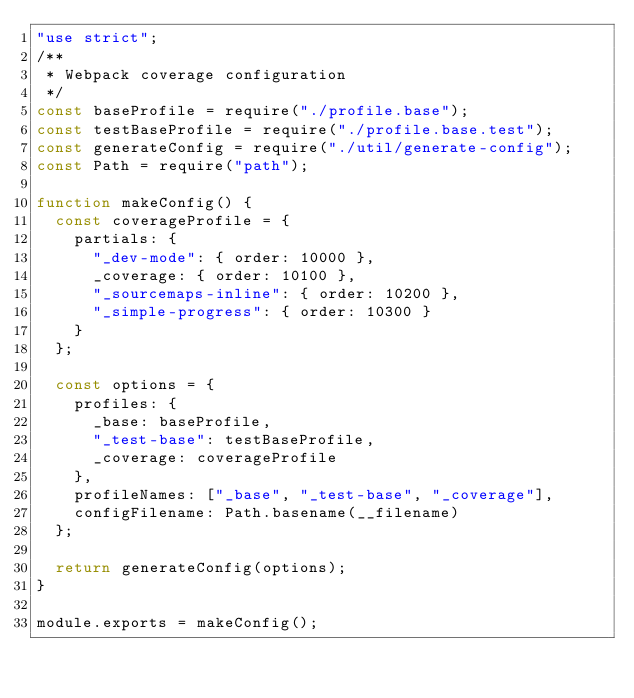<code> <loc_0><loc_0><loc_500><loc_500><_JavaScript_>"use strict";
/**
 * Webpack coverage configuration
 */
const baseProfile = require("./profile.base");
const testBaseProfile = require("./profile.base.test");
const generateConfig = require("./util/generate-config");
const Path = require("path");

function makeConfig() {
  const coverageProfile = {
    partials: {
      "_dev-mode": { order: 10000 },
      _coverage: { order: 10100 },
      "_sourcemaps-inline": { order: 10200 },
      "_simple-progress": { order: 10300 }
    }
  };

  const options = {
    profiles: {
      _base: baseProfile,
      "_test-base": testBaseProfile,
      _coverage: coverageProfile
    },
    profileNames: ["_base", "_test-base", "_coverage"],
    configFilename: Path.basename(__filename)
  };

  return generateConfig(options);
}

module.exports = makeConfig();
</code> 